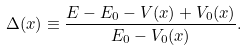<formula> <loc_0><loc_0><loc_500><loc_500>\Delta ( x ) \equiv \frac { E - E _ { 0 } - V ( x ) + V _ { 0 } ( x ) } { E _ { 0 } - V _ { 0 } ( x ) } .</formula> 